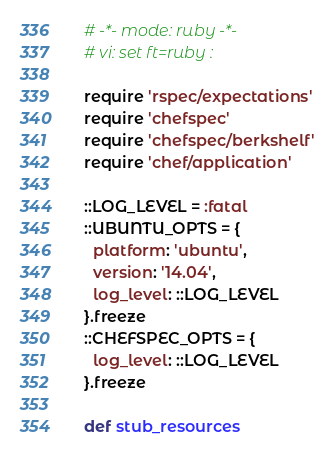Convert code to text. <code><loc_0><loc_0><loc_500><loc_500><_Ruby_>
# -*- mode: ruby -*-
# vi: set ft=ruby :

require 'rspec/expectations'
require 'chefspec'
require 'chefspec/berkshelf'
require 'chef/application'

::LOG_LEVEL = :fatal
::UBUNTU_OPTS = {
  platform: 'ubuntu',
  version: '14.04',
  log_level: ::LOG_LEVEL
}.freeze
::CHEFSPEC_OPTS = {
  log_level: ::LOG_LEVEL
}.freeze

def stub_resources</code> 